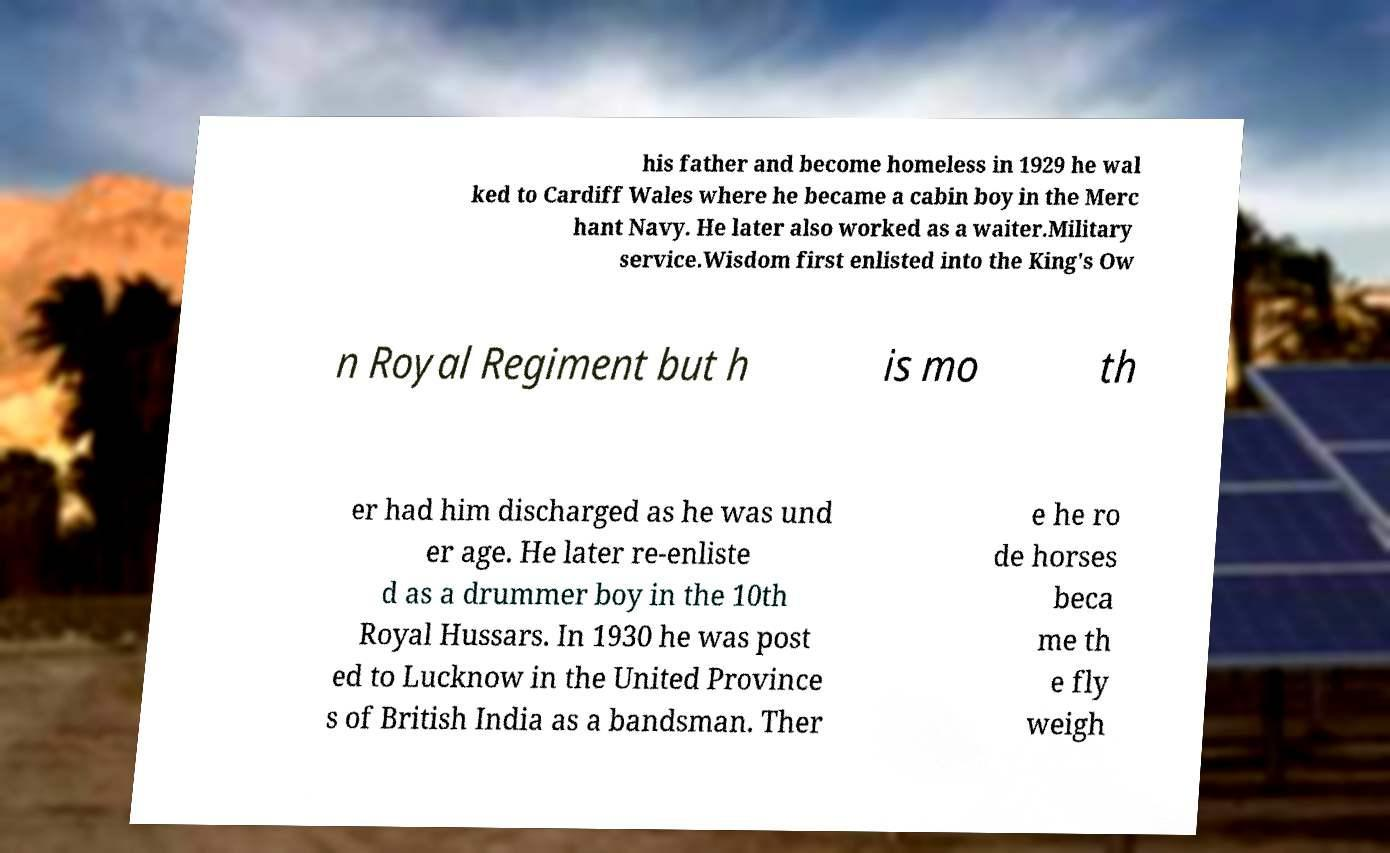Could you assist in decoding the text presented in this image and type it out clearly? his father and become homeless in 1929 he wal ked to Cardiff Wales where he became a cabin boy in the Merc hant Navy. He later also worked as a waiter.Military service.Wisdom first enlisted into the King's Ow n Royal Regiment but h is mo th er had him discharged as he was und er age. He later re-enliste d as a drummer boy in the 10th Royal Hussars. In 1930 he was post ed to Lucknow in the United Province s of British India as a bandsman. Ther e he ro de horses beca me th e fly weigh 